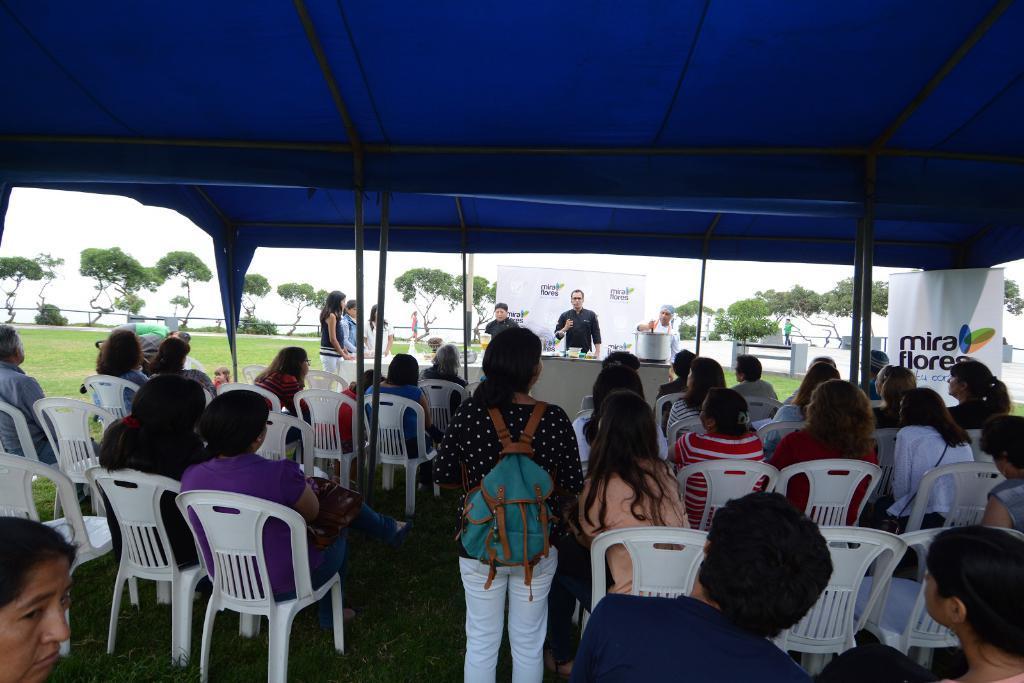Could you give a brief overview of what you see in this image? There are a group of people sitting on a chair. There is a woman standing at the center. Here is a man standing and looks like he is giving instructions to the people who are sitting. In the background there are trees. 